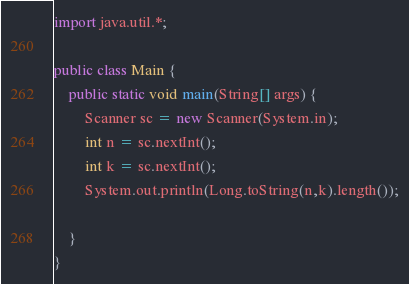<code> <loc_0><loc_0><loc_500><loc_500><_Java_>import java.util.*;

public class Main {
    public static void main(String[] args) {
        Scanner sc = new Scanner(System.in);
        int n = sc.nextInt();
        int k = sc.nextInt();
        System.out.println(Long.toString(n,k).length());

    }
}
</code> 